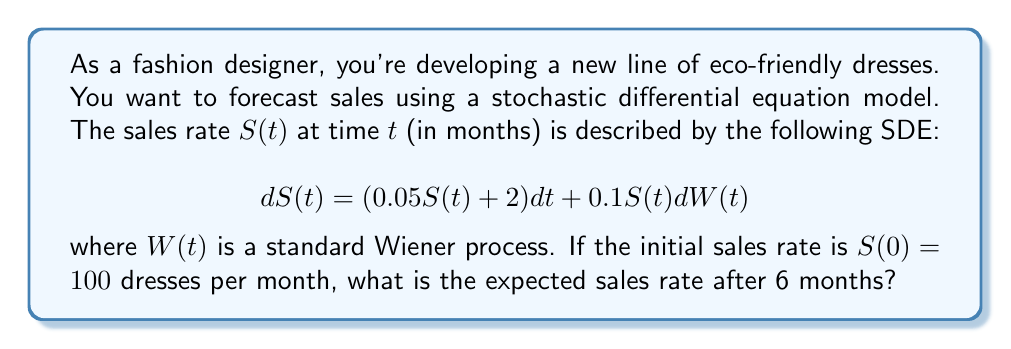Provide a solution to this math problem. To solve this problem, we need to follow these steps:

1) The given SDE is of the form:
   $$dS(t) = (\mu S(t) + \alpha)dt + \sigma S(t)dW(t)$$
   where $\mu = 0.05$, $\alpha = 2$, and $\sigma = 0.1$

2) For this type of SDE, the expected value of $S(t)$ is given by:
   $$E[S(t)] = (S(0) + \frac{\alpha}{\mu})e^{\mu t} - \frac{\alpha}{\mu}$$

3) Substituting the given values:
   $$E[S(t)] = (100 + \frac{2}{0.05})e^{0.05t} - \frac{2}{0.05}$$

4) Simplify:
   $$E[S(t)] = (100 + 40)e^{0.05t} - 40$$
   $$E[S(t)] = 140e^{0.05t} - 40$$

5) We want to find $E[S(6)]$, so let $t = 6$:
   $$E[S(6)] = 140e^{0.05(6)} - 40$$

6) Calculate:
   $$E[S(6)] = 140e^{0.3} - 40$$
   $$E[S(6)] = 140(1.34986) - 40$$
   $$E[S(6)] = 188.98 - 40 = 148.98$$

Therefore, the expected sales rate after 6 months is approximately 148.98 dresses per month.
Answer: 148.98 dresses per month 